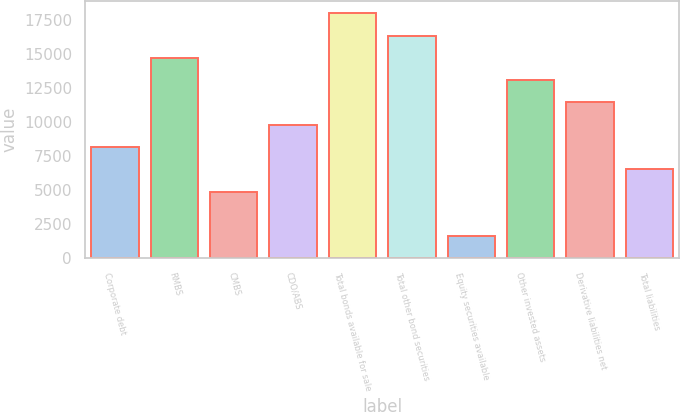<chart> <loc_0><loc_0><loc_500><loc_500><bar_chart><fcel>Corporate debt<fcel>RMBS<fcel>CMBS<fcel>CDO/ABS<fcel>Total bonds available for sale<fcel>Total other bond securities<fcel>Equity securities available<fcel>Other invested assets<fcel>Derivative liabilities net<fcel>Total liabilities<nl><fcel>8183<fcel>14728.6<fcel>4910.2<fcel>9819.4<fcel>18001.4<fcel>16365<fcel>1637.4<fcel>13092.2<fcel>11455.8<fcel>6546.6<nl></chart> 